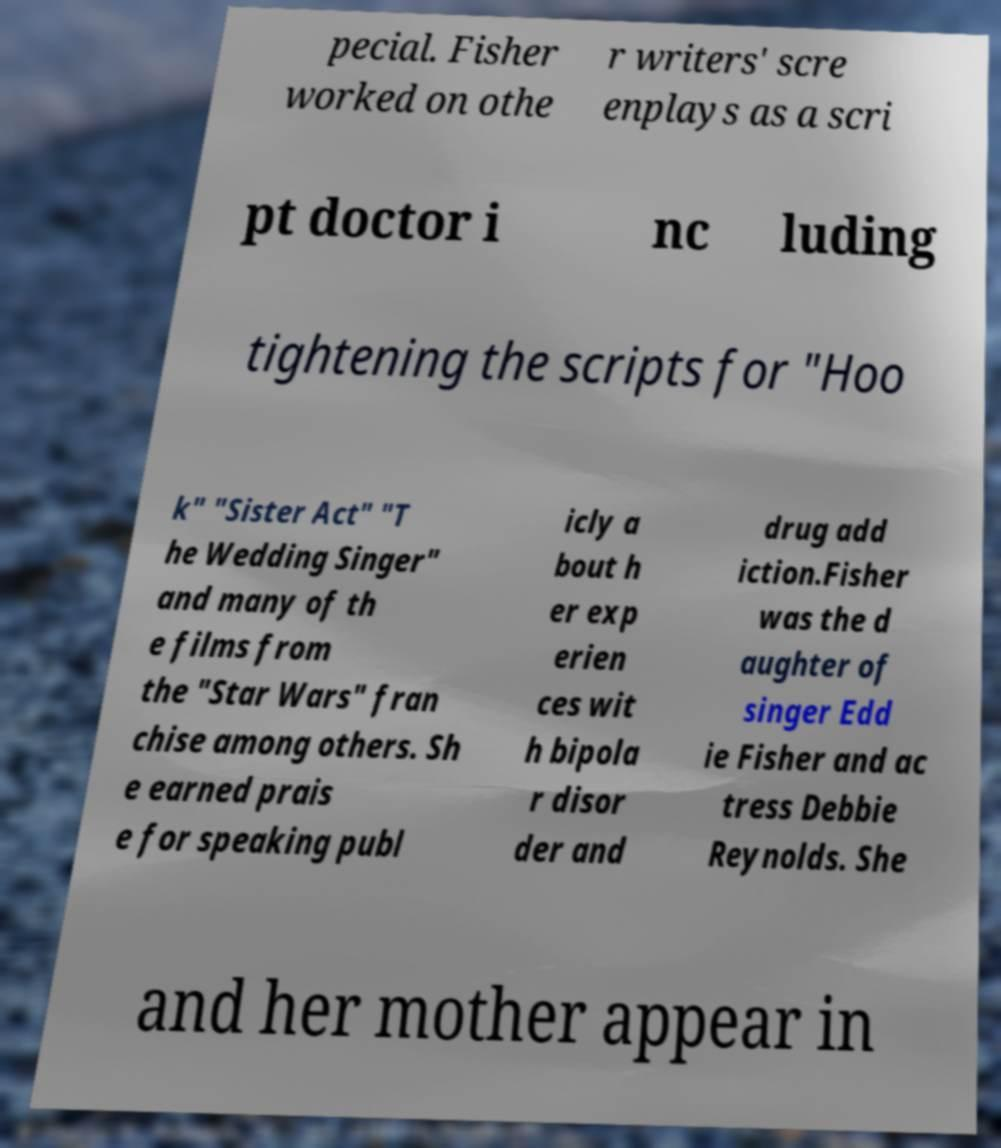What messages or text are displayed in this image? I need them in a readable, typed format. pecial. Fisher worked on othe r writers' scre enplays as a scri pt doctor i nc luding tightening the scripts for "Hoo k" "Sister Act" "T he Wedding Singer" and many of th e films from the "Star Wars" fran chise among others. Sh e earned prais e for speaking publ icly a bout h er exp erien ces wit h bipola r disor der and drug add iction.Fisher was the d aughter of singer Edd ie Fisher and ac tress Debbie Reynolds. She and her mother appear in 